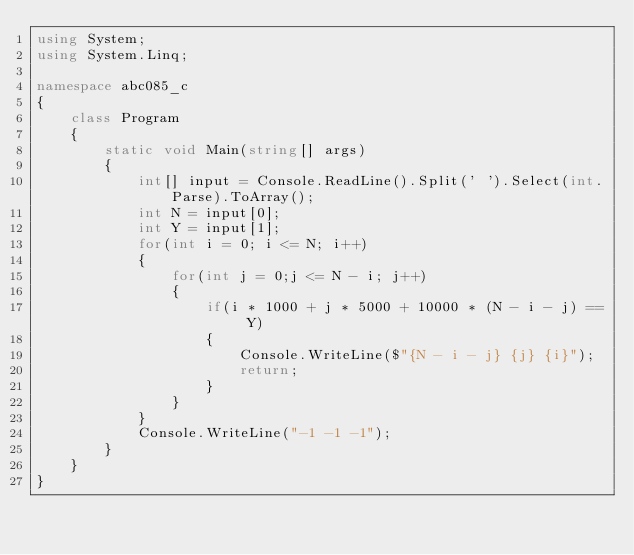<code> <loc_0><loc_0><loc_500><loc_500><_C#_>using System;
using System.Linq;

namespace abc085_c
{
    class Program
    {
        static void Main(string[] args)
        {
            int[] input = Console.ReadLine().Split(' ').Select(int.Parse).ToArray();
            int N = input[0];
            int Y = input[1];
            for(int i = 0; i <= N; i++)
            {
                for(int j = 0;j <= N - i; j++)
                {
                    if(i * 1000 + j * 5000 + 10000 * (N - i - j) == Y)
                    {
                        Console.WriteLine($"{N - i - j} {j} {i}");
                        return;
                    }
                }
            }
            Console.WriteLine("-1 -1 -1");
        }
    }
}
</code> 